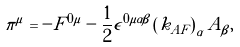<formula> <loc_0><loc_0><loc_500><loc_500>\pi ^ { \mu } = - F ^ { 0 \mu } - \frac { 1 } { 2 } \epsilon ^ { 0 \mu \alpha \beta } \left ( k _ { A F } \right ) _ { \alpha } A _ { \beta } ,</formula> 